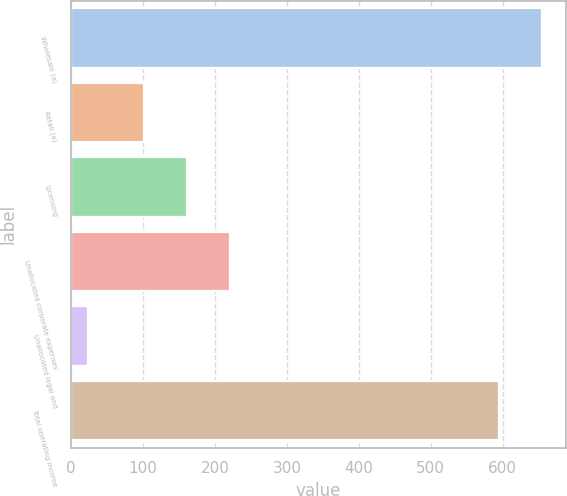Convert chart. <chart><loc_0><loc_0><loc_500><loc_500><bar_chart><fcel>Wholesale (a)<fcel>Retail (a)<fcel>Licensing<fcel>Unallocated corporate expenses<fcel>Unallocated legal and<fcel>Total operating income<nl><fcel>655.18<fcel>101.6<fcel>161.28<fcel>220.96<fcel>23.1<fcel>595.5<nl></chart> 